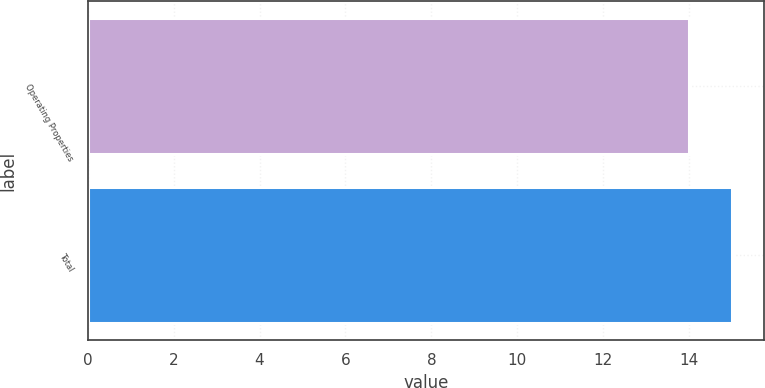<chart> <loc_0><loc_0><loc_500><loc_500><bar_chart><fcel>Operating Properties<fcel>Total<nl><fcel>14<fcel>15<nl></chart> 